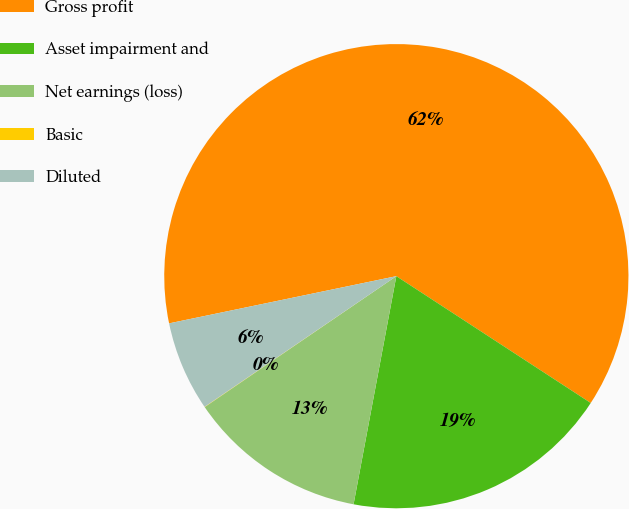Convert chart to OTSL. <chart><loc_0><loc_0><loc_500><loc_500><pie_chart><fcel>Gross profit<fcel>Asset impairment and<fcel>Net earnings (loss)<fcel>Basic<fcel>Diluted<nl><fcel>62.46%<fcel>18.75%<fcel>12.51%<fcel>0.02%<fcel>6.26%<nl></chart> 